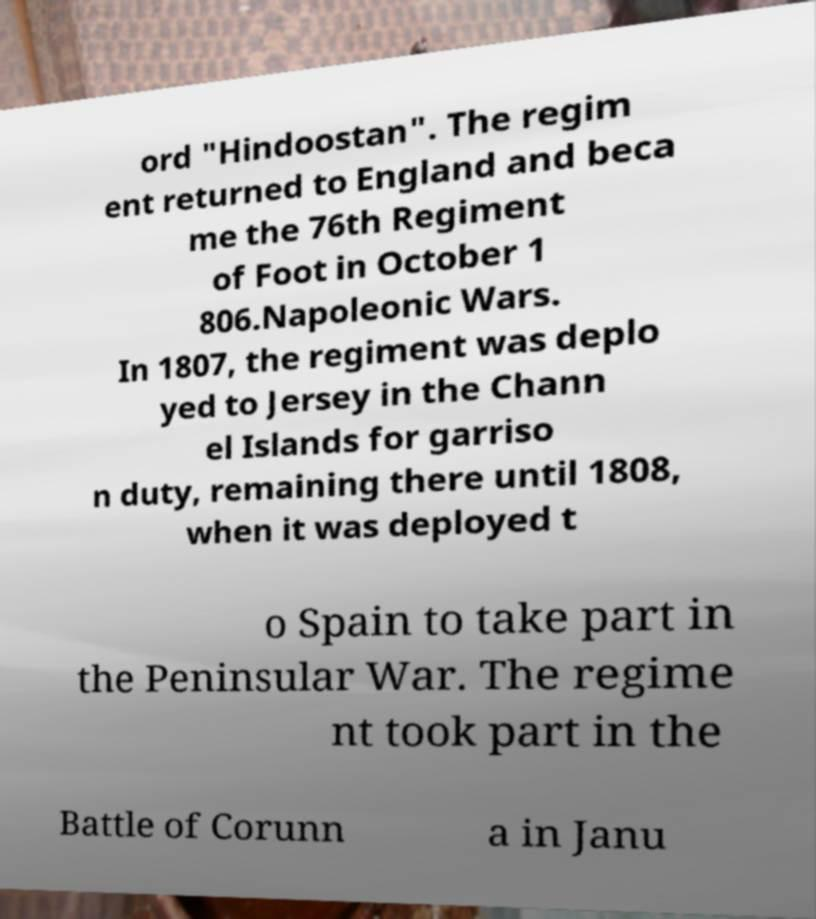Could you extract and type out the text from this image? ord "Hindoostan". The regim ent returned to England and beca me the 76th Regiment of Foot in October 1 806.Napoleonic Wars. In 1807, the regiment was deplo yed to Jersey in the Chann el Islands for garriso n duty, remaining there until 1808, when it was deployed t o Spain to take part in the Peninsular War. The regime nt took part in the Battle of Corunn a in Janu 